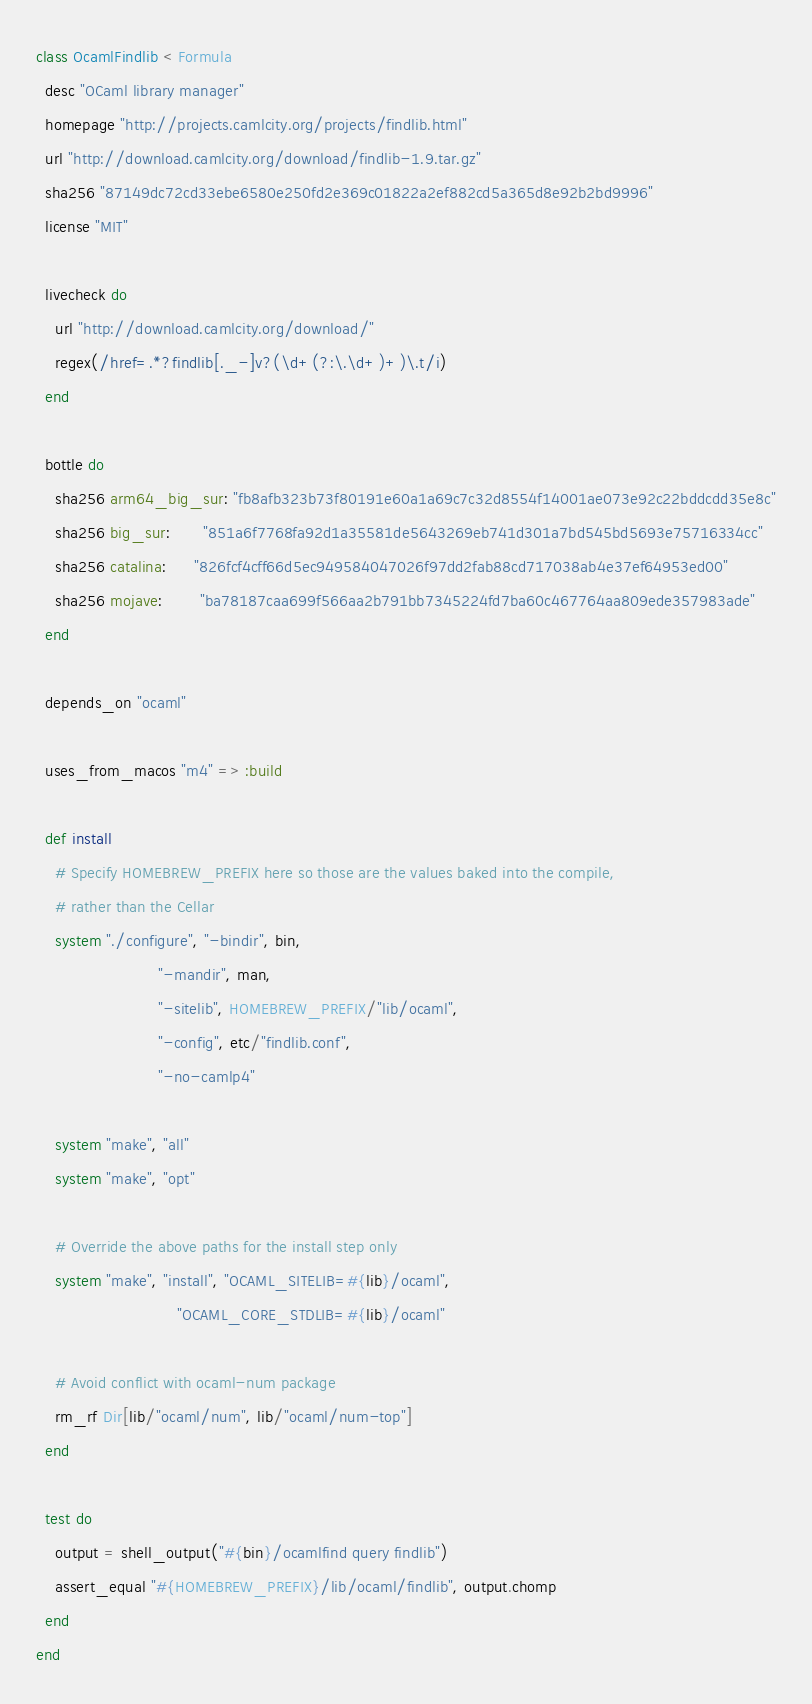<code> <loc_0><loc_0><loc_500><loc_500><_Ruby_>class OcamlFindlib < Formula
  desc "OCaml library manager"
  homepage "http://projects.camlcity.org/projects/findlib.html"
  url "http://download.camlcity.org/download/findlib-1.9.tar.gz"
  sha256 "87149dc72cd33ebe6580e250fd2e369c01822a2ef882cd5a365d8e92b2bd9996"
  license "MIT"

  livecheck do
    url "http://download.camlcity.org/download/"
    regex(/href=.*?findlib[._-]v?(\d+(?:\.\d+)+)\.t/i)
  end

  bottle do
    sha256 arm64_big_sur: "fb8afb323b73f80191e60a1a69c7c32d8554f14001ae073e92c22bddcdd35e8c"
    sha256 big_sur:       "851a6f7768fa92d1a35581de5643269eb741d301a7bd545bd5693e75716334cc"
    sha256 catalina:      "826fcf4cff66d5ec949584047026f97dd2fab88cd717038ab4e37ef64953ed00"
    sha256 mojave:        "ba78187caa699f566aa2b791bb7345224fd7ba60c467764aa809ede357983ade"
  end

  depends_on "ocaml"

  uses_from_macos "m4" => :build

  def install
    # Specify HOMEBREW_PREFIX here so those are the values baked into the compile,
    # rather than the Cellar
    system "./configure", "-bindir", bin,
                          "-mandir", man,
                          "-sitelib", HOMEBREW_PREFIX/"lib/ocaml",
                          "-config", etc/"findlib.conf",
                          "-no-camlp4"

    system "make", "all"
    system "make", "opt"

    # Override the above paths for the install step only
    system "make", "install", "OCAML_SITELIB=#{lib}/ocaml",
                              "OCAML_CORE_STDLIB=#{lib}/ocaml"

    # Avoid conflict with ocaml-num package
    rm_rf Dir[lib/"ocaml/num", lib/"ocaml/num-top"]
  end

  test do
    output = shell_output("#{bin}/ocamlfind query findlib")
    assert_equal "#{HOMEBREW_PREFIX}/lib/ocaml/findlib", output.chomp
  end
end
</code> 